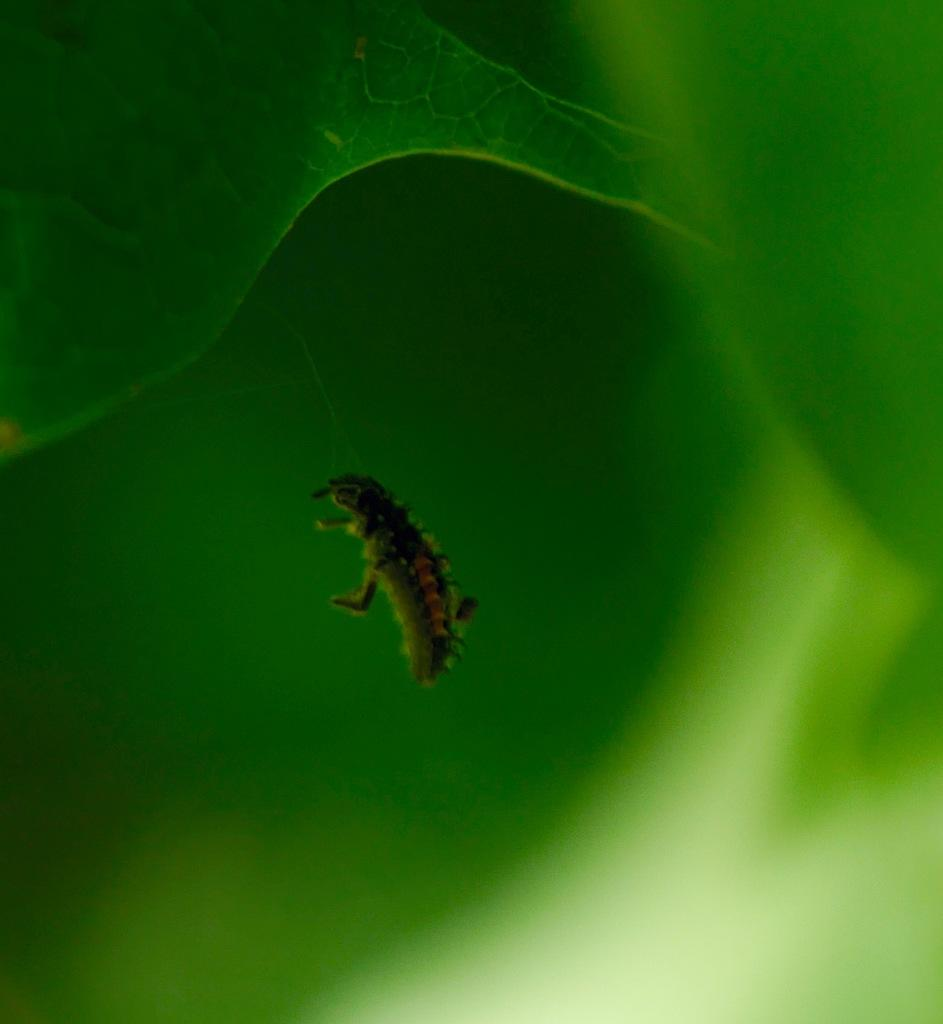What type of creatures are present in the image? There are pests in the image. What else can be seen in the image besides the pests? There are leaves in the image. What is the weight of the popcorn in the image? There is no popcorn present in the image. What does the tongue of the pest look like in the image? There is no information about the tongue of the pest in the image. 